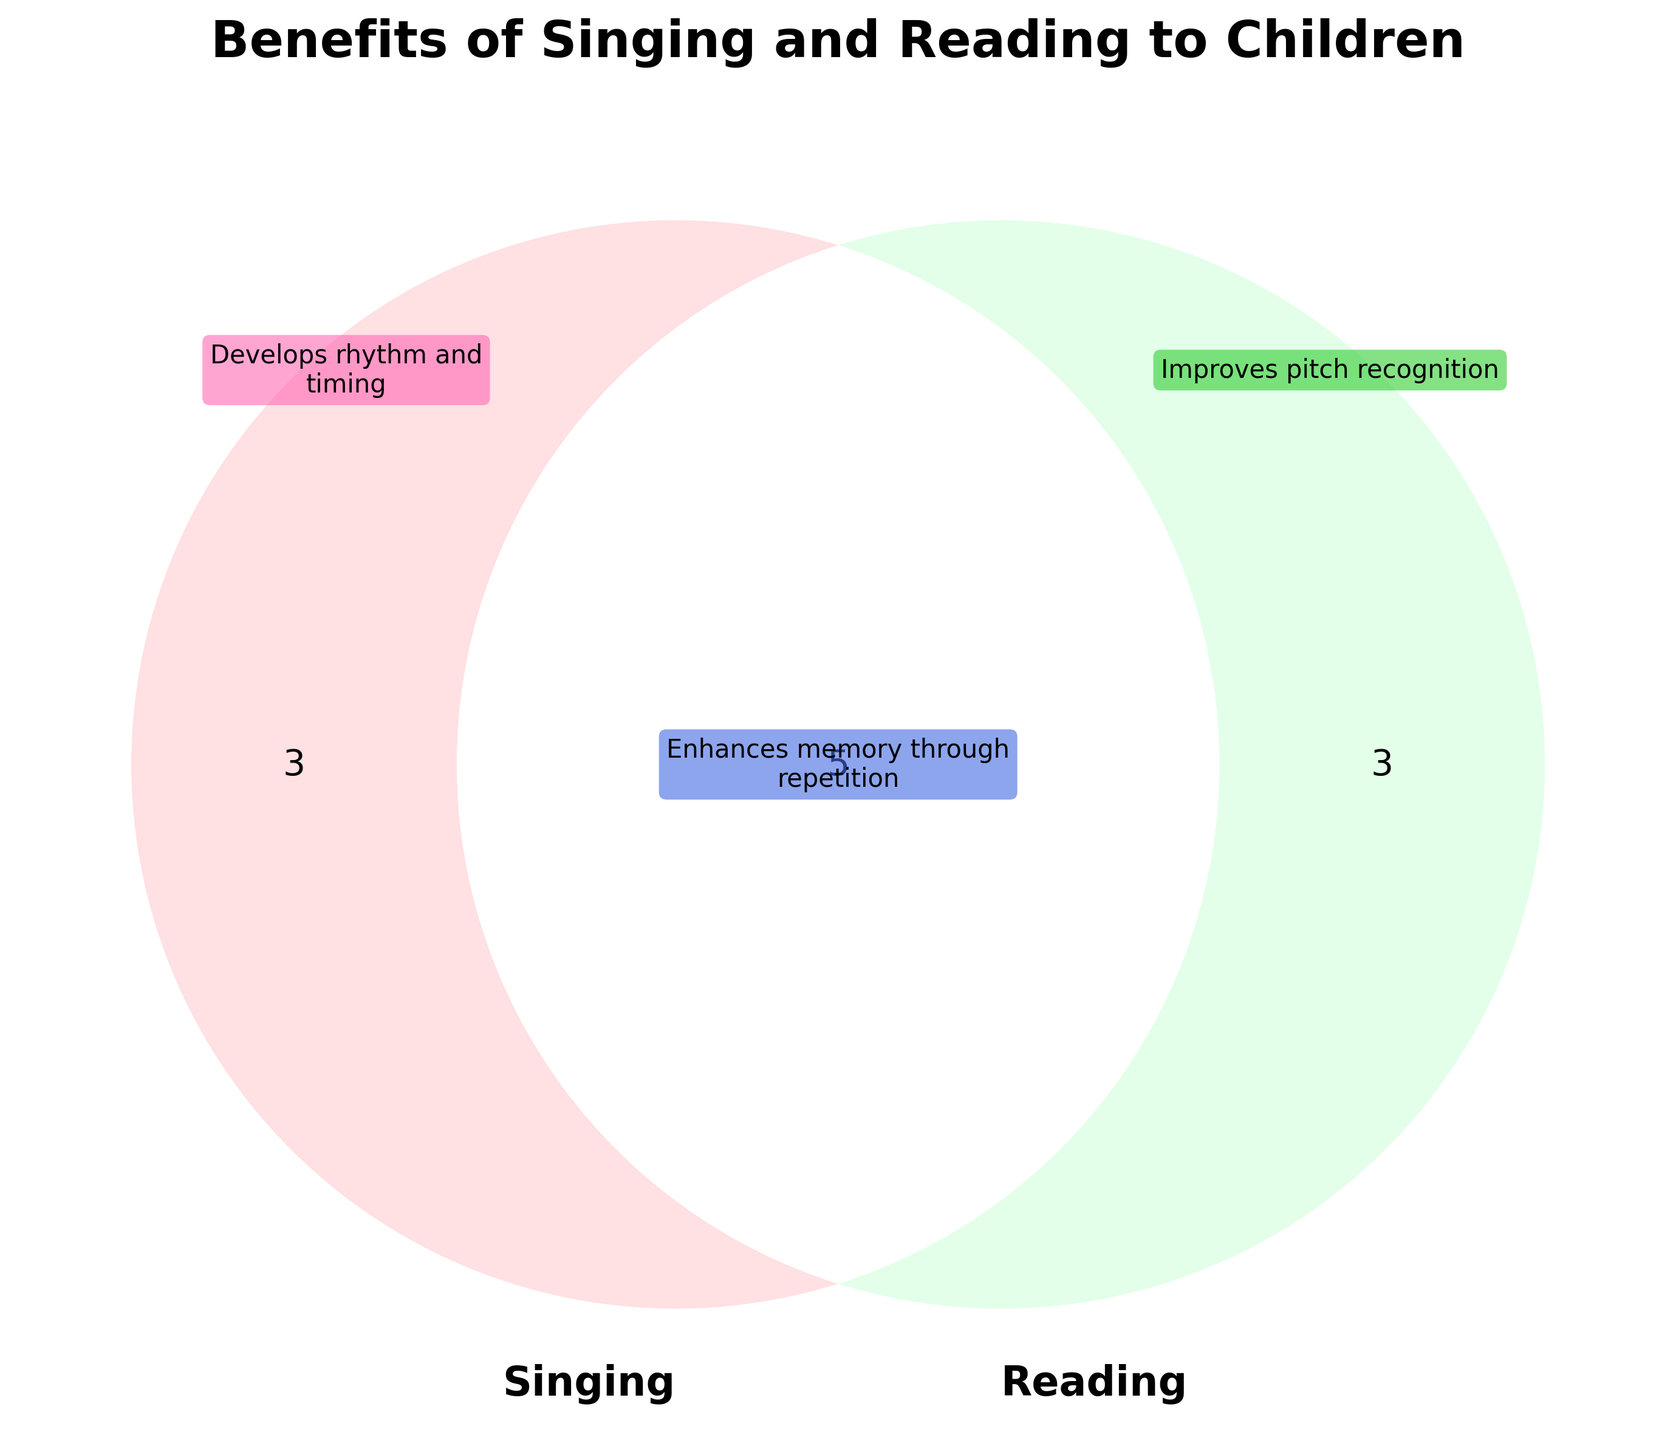What is the title of the figure? The title of the figure is usually displayed at the top. In this case, it reads "Benefits of Singing and Reading to Children".
Answer: Benefits of Singing and Reading to Children How many benefits are unique to singing? By examining the section labeled "Singing Only" in the Venn diagram, you can count the benefits listed. There are three benefits unique to singing.
Answer: 3 Which shared benefit can enhance language development? Look at the section where both circles overlap. One of the shared benefits listed is "Boosts language development".
Answer: Boosts language development What are the unique benefits of reading? Observe the section labeled "Reading Only" in the Venn diagram. The benefits listed there are "Introduces complex vocabulary", "Improves visual literacy", and "Develops storytelling skills".
Answer: Introduces complex vocabulary, Improves visual literacy, Develops storytelling skills Which activity helps in improving cognitive abilities? Identify the benefit "Improves cognitive abilities" and see where it is placed. It appears in the overlapping region, indicating it is a benefit of both singing and reading.
Answer: Both How many total benefits are there combined (both unique and shared)? Sum up the number of benefits in each section: 3 (Singing Only) + 3 (Reading Only) + 5 (Both) = 11 benefits in total.
Answer: 11 Which activity (singing or reading) has more unique benefits? Compare the number of unique benefits in each section. Both singing and reading have 3 unique benefits each, so they are equal.
Answer: Equal What benefit does "Enhances listening skills" fall under? Locate the benefit "Enhances listening skills" on the diagram. It is placed in the overlapping section, meaning it is a benefit of both activities.
Answer: Both Does singing help in developing storytelling skills? Check if "Develops storytelling skills" is listed under the Singing Only section. It is not; it is under Reading Only, so singing does not have this benefit.
Answer: No How many shared benefits are there? Count the number of benefits listed in the overlapping section where both circles meet. There are five shared benefits.
Answer: 5 